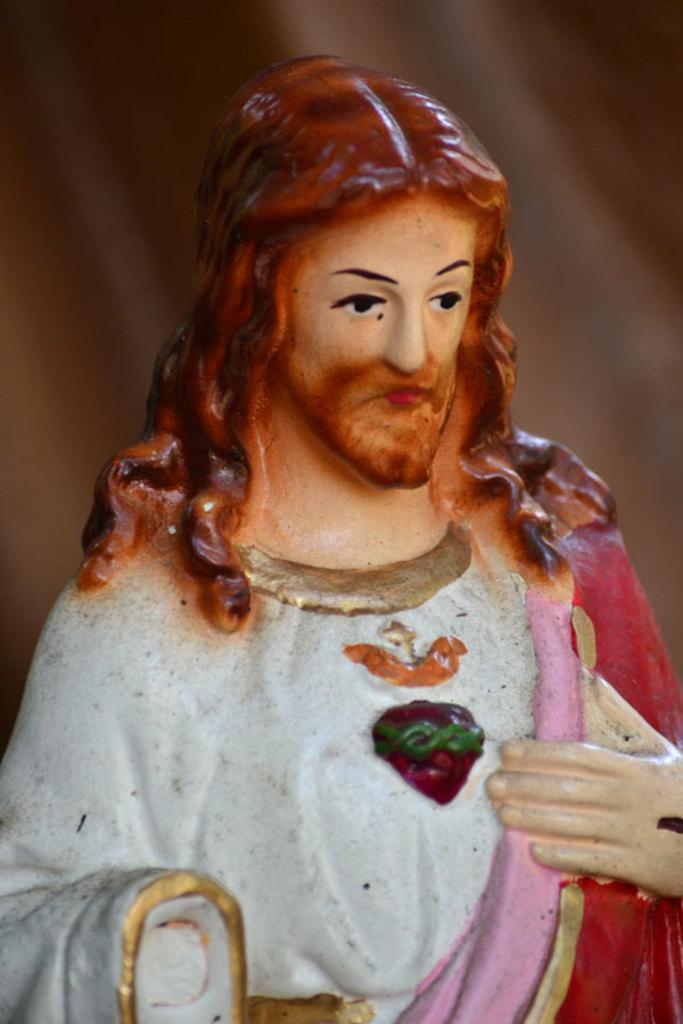Describe this image in one or two sentences. In this image we can see the depiction of a Jesus Christ. 